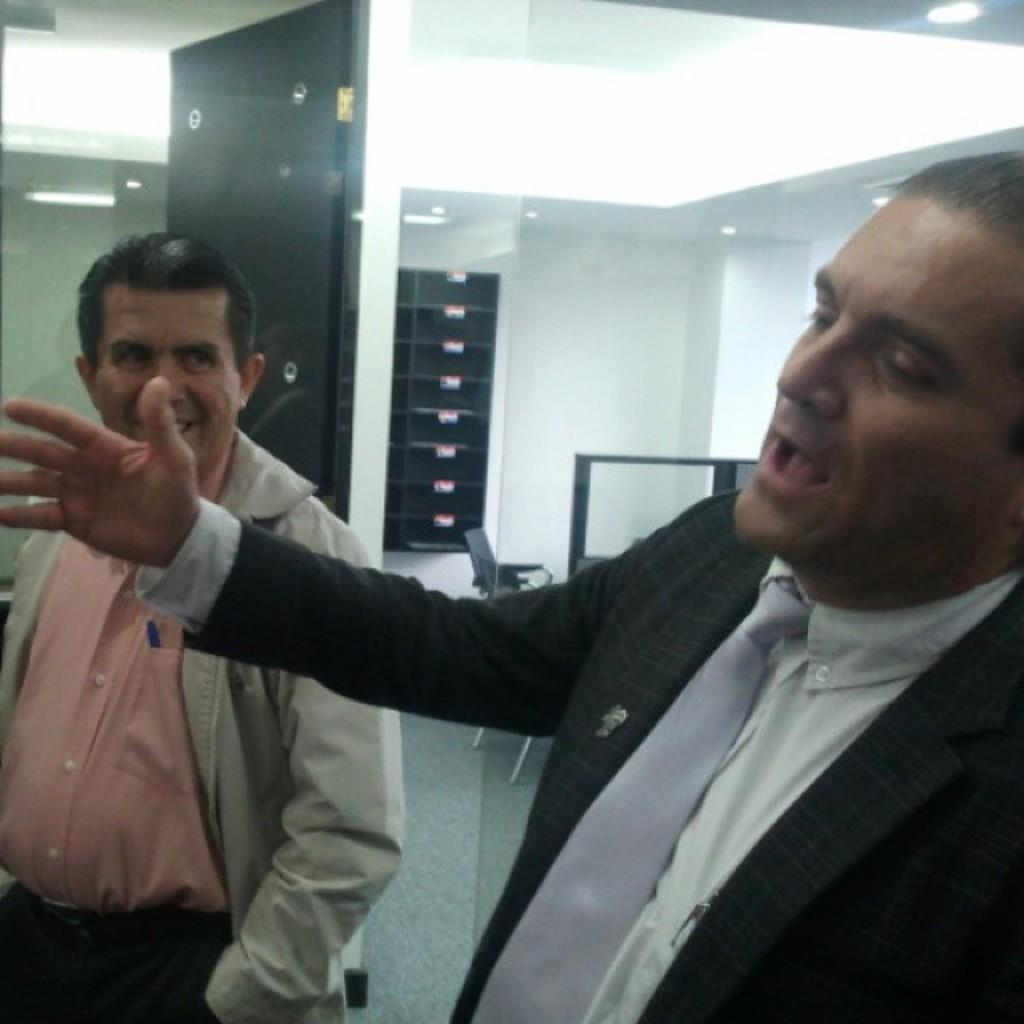Please provide a concise description of this image. There are two men standing. This looks like a glass door. These are the ceiling lights, which are attached to the roof. I can see a chair. I think this is the wooden door. 